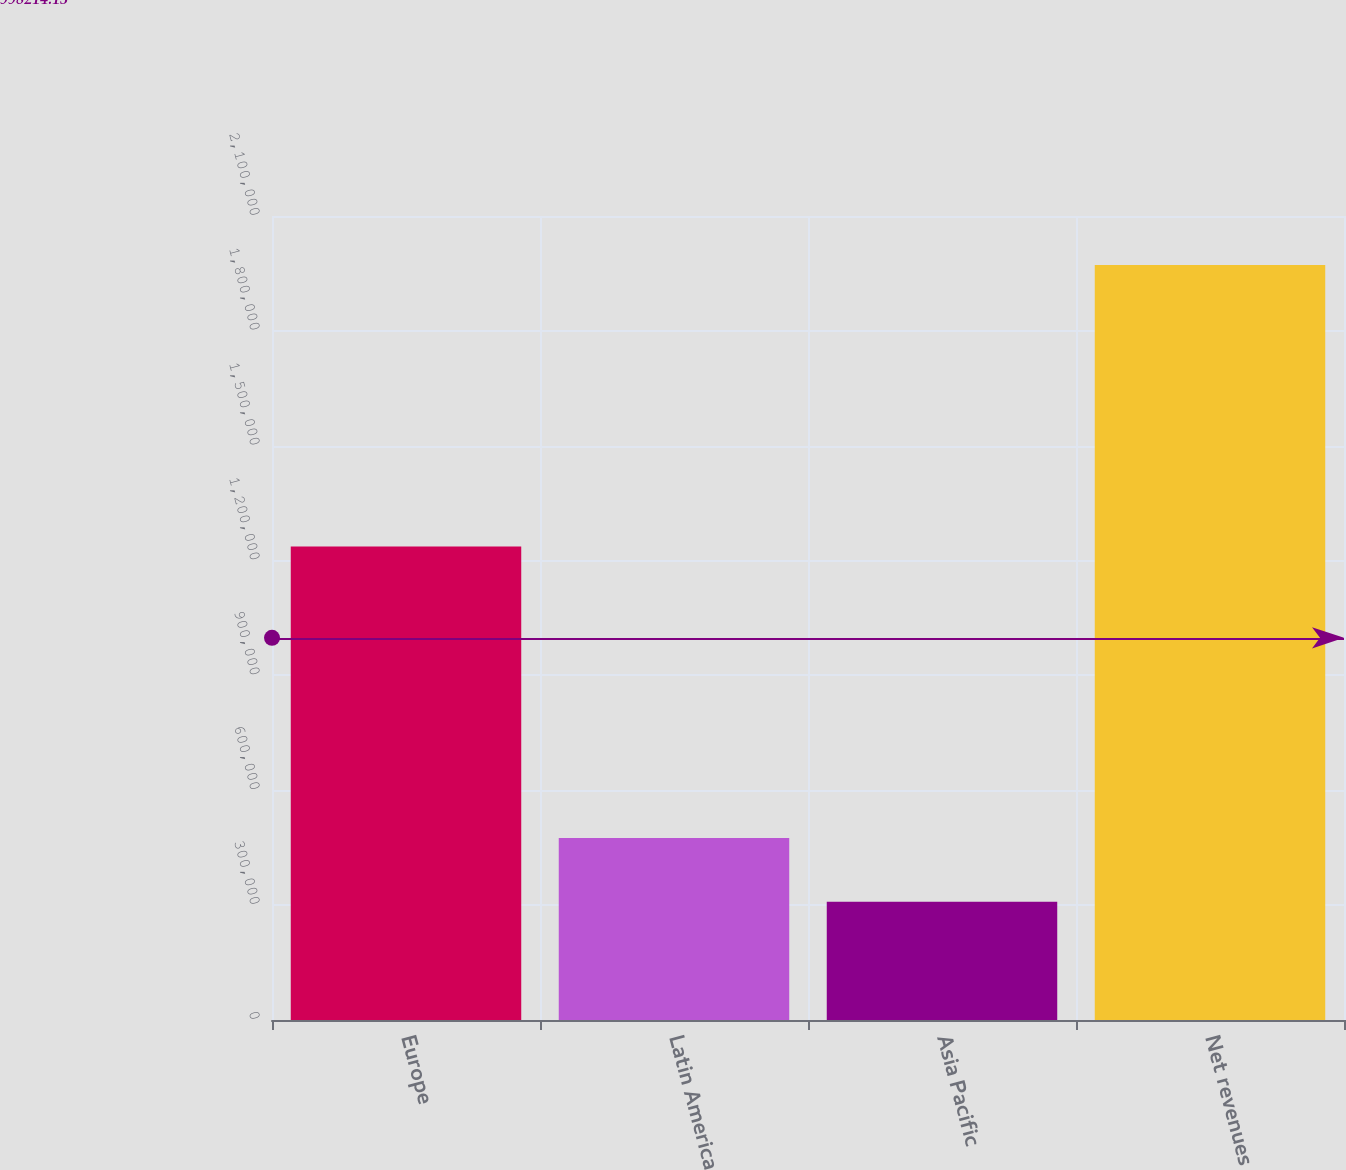<chart> <loc_0><loc_0><loc_500><loc_500><bar_chart><fcel>Europe<fcel>Latin America<fcel>Asia Pacific<fcel>Net revenues<nl><fcel>1.23685e+06<fcel>475216<fcel>308920<fcel>1.97188e+06<nl></chart> 